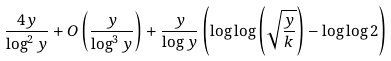Convert formula to latex. <formula><loc_0><loc_0><loc_500><loc_500>\frac { 4 y } { \log ^ { 2 } y } + O \left ( \frac { y } { \log ^ { 3 } y } \right ) + \frac { y } { \log y } \left ( \log \log \left ( \sqrt { \frac { y } { k } } \right ) - \log \log 2 \right )</formula> 